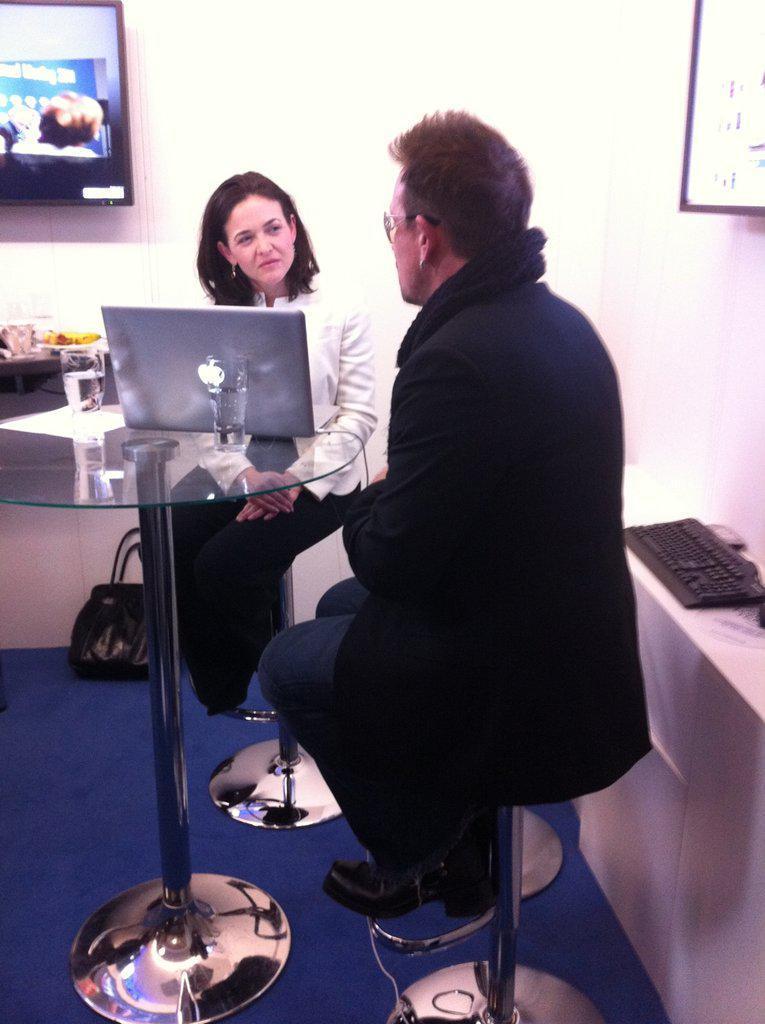Can you describe this image briefly? In this picture there are two people, a woman and man. The woman is looking at man and there is a table in front of them with water glass a laptop and onto the right side there is the keyboard and on the left there is a television 